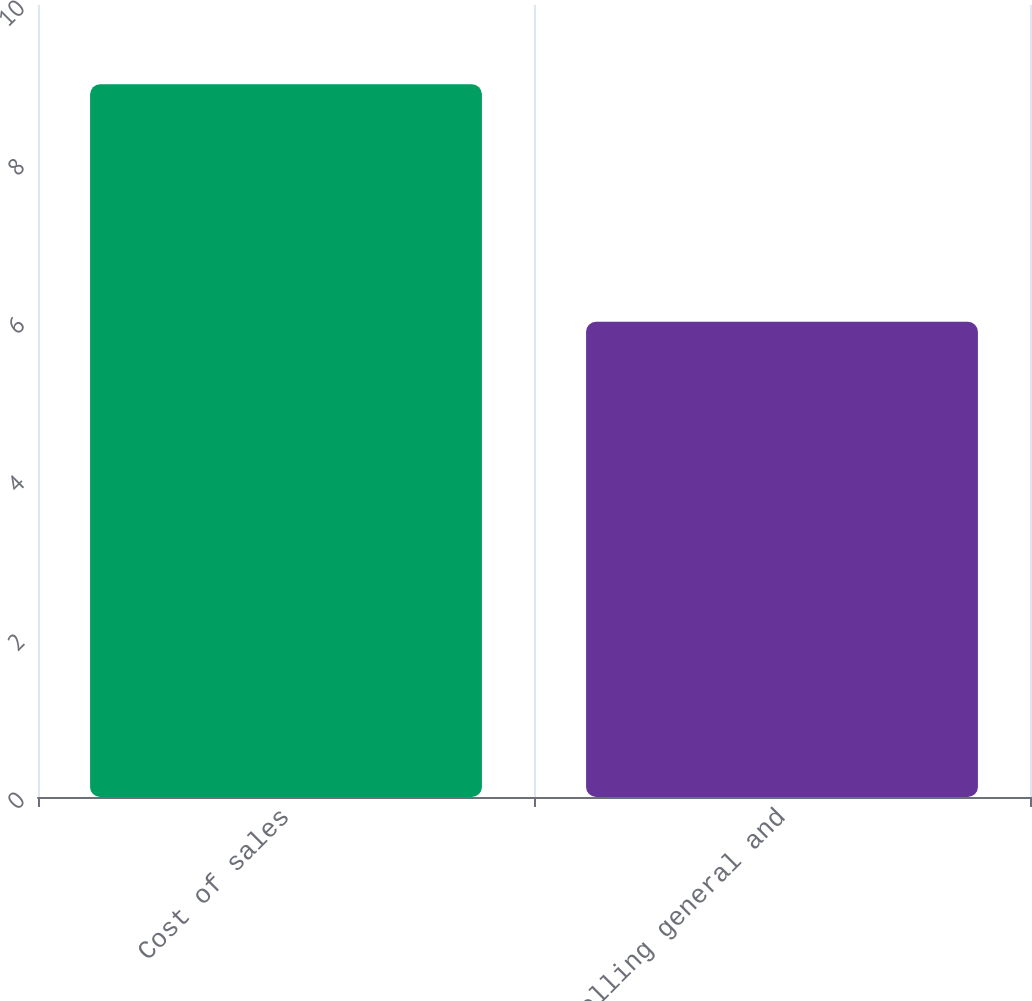Convert chart. <chart><loc_0><loc_0><loc_500><loc_500><bar_chart><fcel>Cost of sales<fcel>Selling general and<nl><fcel>9<fcel>6<nl></chart> 